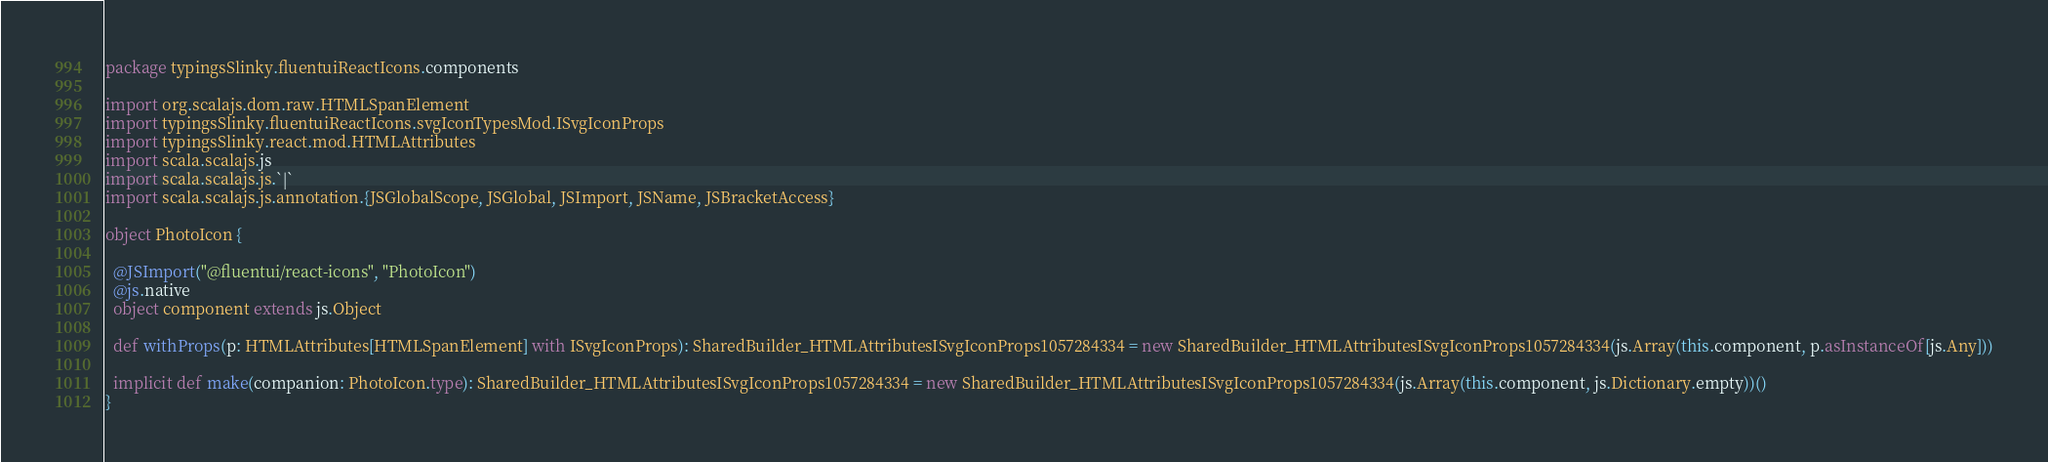Convert code to text. <code><loc_0><loc_0><loc_500><loc_500><_Scala_>package typingsSlinky.fluentuiReactIcons.components

import org.scalajs.dom.raw.HTMLSpanElement
import typingsSlinky.fluentuiReactIcons.svgIconTypesMod.ISvgIconProps
import typingsSlinky.react.mod.HTMLAttributes
import scala.scalajs.js
import scala.scalajs.js.`|`
import scala.scalajs.js.annotation.{JSGlobalScope, JSGlobal, JSImport, JSName, JSBracketAccess}

object PhotoIcon {
  
  @JSImport("@fluentui/react-icons", "PhotoIcon")
  @js.native
  object component extends js.Object
  
  def withProps(p: HTMLAttributes[HTMLSpanElement] with ISvgIconProps): SharedBuilder_HTMLAttributesISvgIconProps1057284334 = new SharedBuilder_HTMLAttributesISvgIconProps1057284334(js.Array(this.component, p.asInstanceOf[js.Any]))
  
  implicit def make(companion: PhotoIcon.type): SharedBuilder_HTMLAttributesISvgIconProps1057284334 = new SharedBuilder_HTMLAttributesISvgIconProps1057284334(js.Array(this.component, js.Dictionary.empty))()
}
</code> 